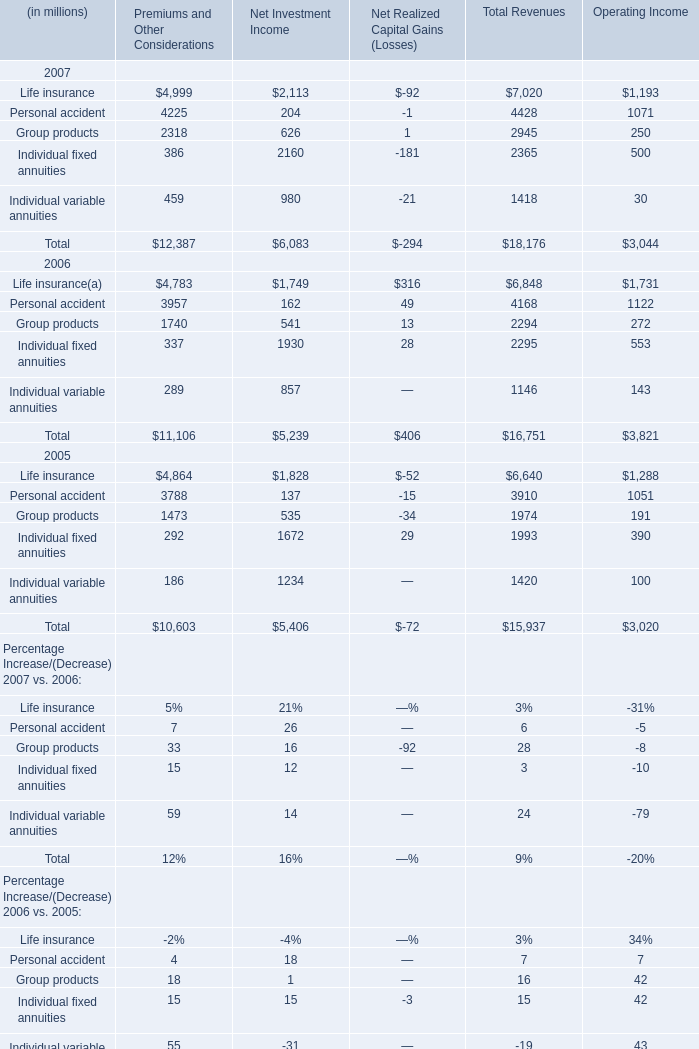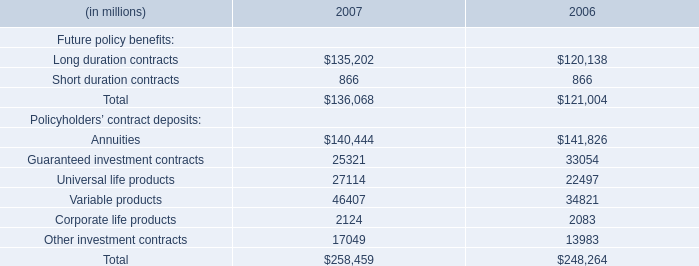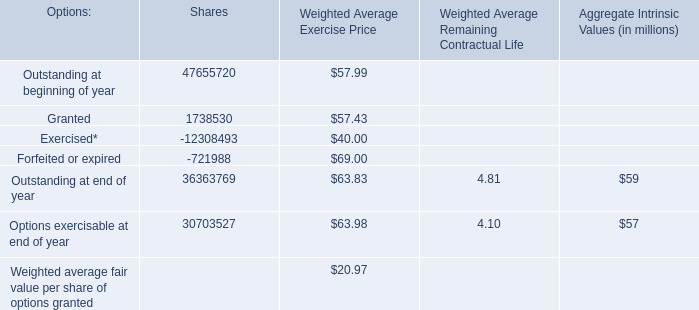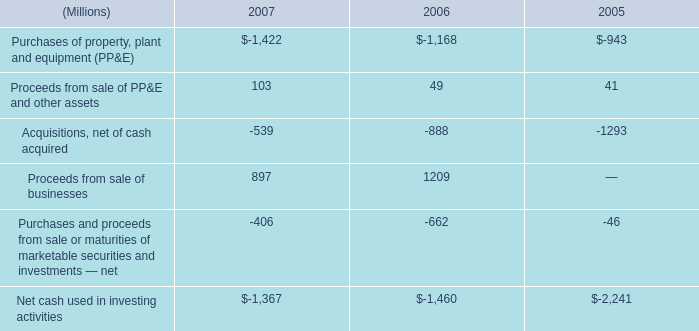In the year with largest amount of Premiums and Other Considerations, what's the increasing rate of Group products? 
Computations: ((((2318 + 626) + 1) - 2294) / 2294)
Answer: 0.28378. 